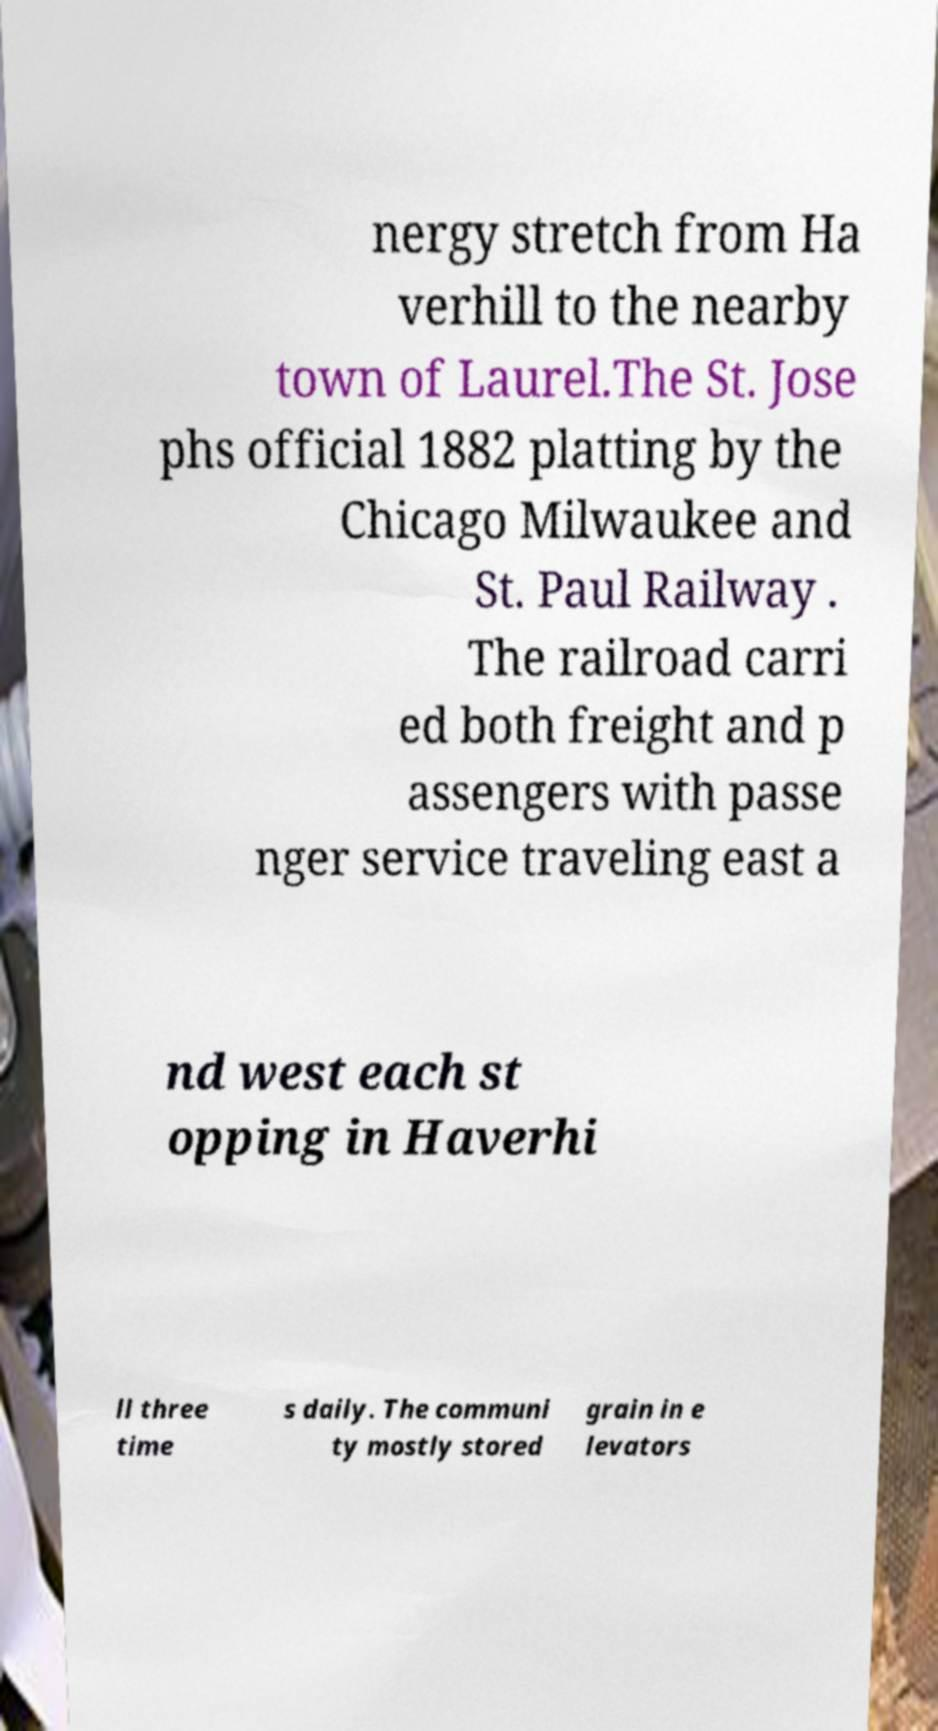Please read and relay the text visible in this image. What does it say? nergy stretch from Ha verhill to the nearby town of Laurel.The St. Jose phs official 1882 platting by the Chicago Milwaukee and St. Paul Railway . The railroad carri ed both freight and p assengers with passe nger service traveling east a nd west each st opping in Haverhi ll three time s daily. The communi ty mostly stored grain in e levators 